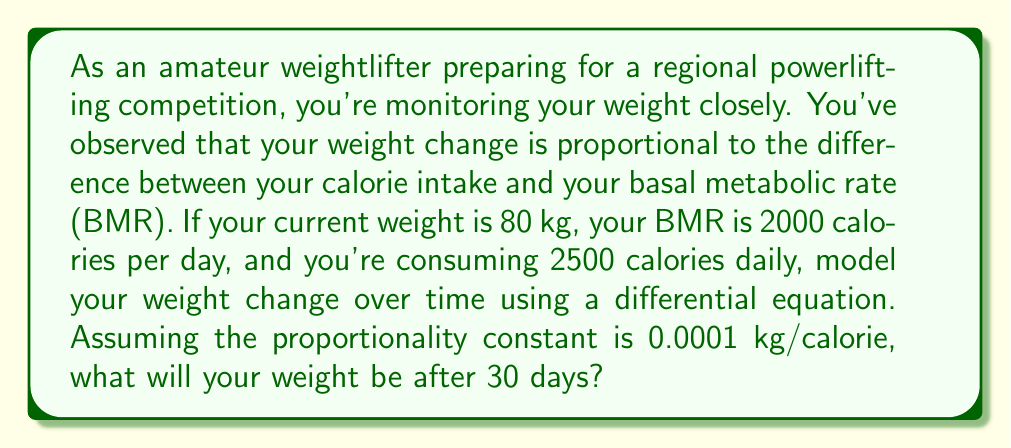Help me with this question. Let's approach this step-by-step:

1) First, we need to set up our differential equation. Let $W(t)$ be your weight in kg at time $t$ in days. The rate of change of weight with respect to time is given by:

   $$\frac{dW}{dt} = k(C - B)$$

   Where:
   - $k$ is the proportionality constant (0.0001 kg/calorie)
   - $C$ is your daily calorie intake (2500 calories)
   - $B$ is your basal metabolic rate (2000 calories)

2) Substituting the given values:

   $$\frac{dW}{dt} = 0.0001(2500 - 2000) = 0.05$$

3) This is a simple first-order differential equation. The general solution is:

   $$W(t) = 0.05t + W_0$$

   Where $W_0$ is your initial weight.

4) We know that $W_0 = 80$ kg, so our specific solution is:

   $$W(t) = 0.05t + 80$$

5) To find your weight after 30 days, we substitute $t = 30$:

   $$W(30) = 0.05(30) + 80 = 1.5 + 80 = 81.5$$

Therefore, after 30 days, your weight will be 81.5 kg.
Answer: 81.5 kg 